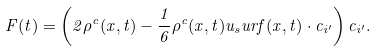Convert formula to latex. <formula><loc_0><loc_0><loc_500><loc_500>F ( t ) = \left ( 2 \rho ^ { c } ( x , t ) - \frac { 1 } { 6 } \rho ^ { c } ( x , t ) u _ { s } u r f ( x , t ) \cdot c _ { i ^ { \prime } } \right ) c _ { i ^ { \prime } } .</formula> 